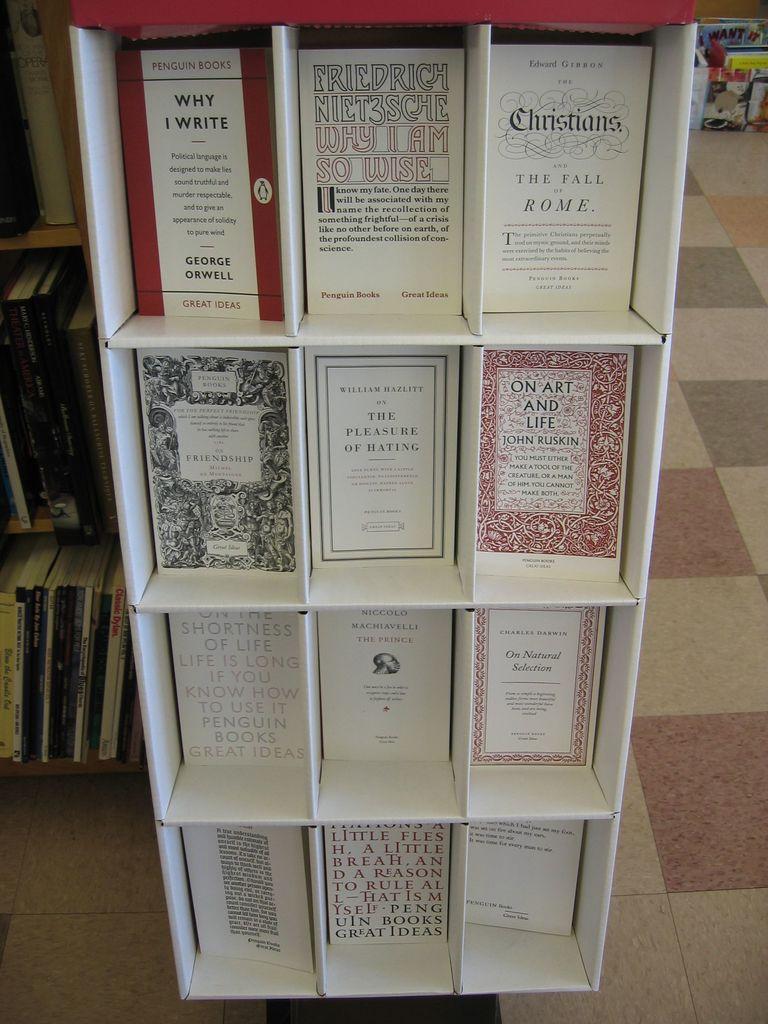What city is the upper right book about?
Make the answer very short. Rome. 